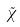<formula> <loc_0><loc_0><loc_500><loc_500>\tilde { \chi }</formula> 